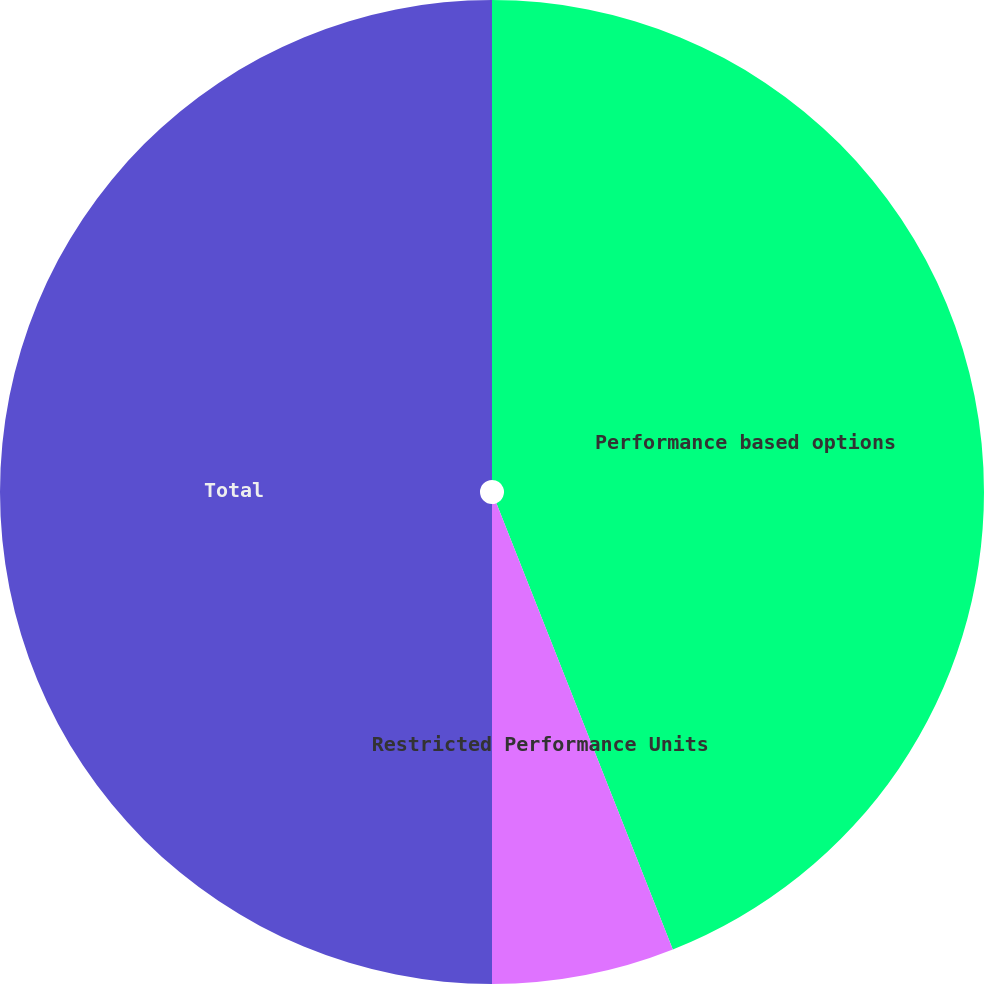Convert chart to OTSL. <chart><loc_0><loc_0><loc_500><loc_500><pie_chart><fcel>Performance based options<fcel>Restricted Performance Units<fcel>Total<nl><fcel>44.01%<fcel>5.99%<fcel>50.0%<nl></chart> 